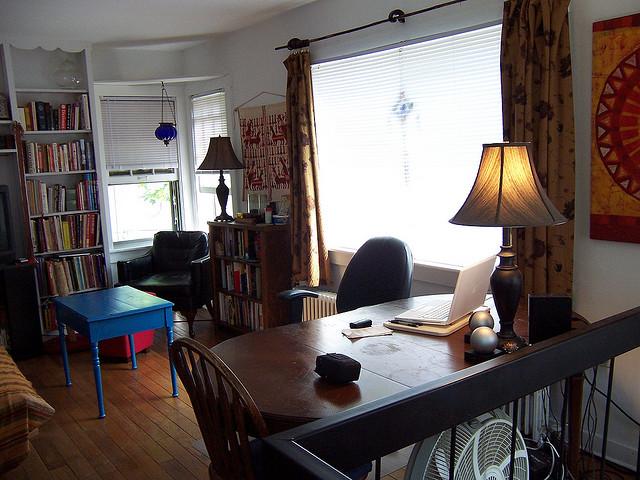How many plants are by the window?
Keep it brief. 0. Was there other people at the table?
Concise answer only. No. Is there room for many more books on the shelves?
Be succinct. No. Is this a living room?
Quick response, please. Yes. Are the curtains closed?
Keep it brief. No. What material is the desk?
Write a very short answer. Wood. How many lamps are turned on in the room?
Give a very brief answer. 1. Is this outside?
Keep it brief. No. 